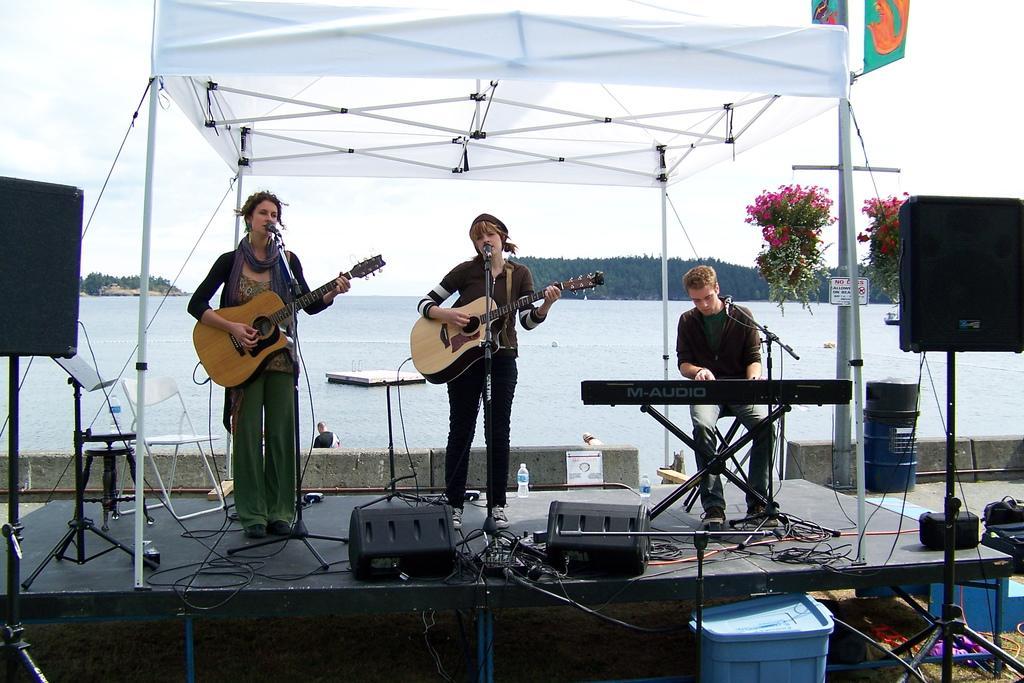Can you describe this image briefly? This is a picture taken in the outdoors, on the stage there are three persons holding a music instrument and singing a song in front of these people there are microphones with stands on the stage there are chair, table, bottles. In front of these people there are speakers with stand. Behind the people there is water, trees and sky. 